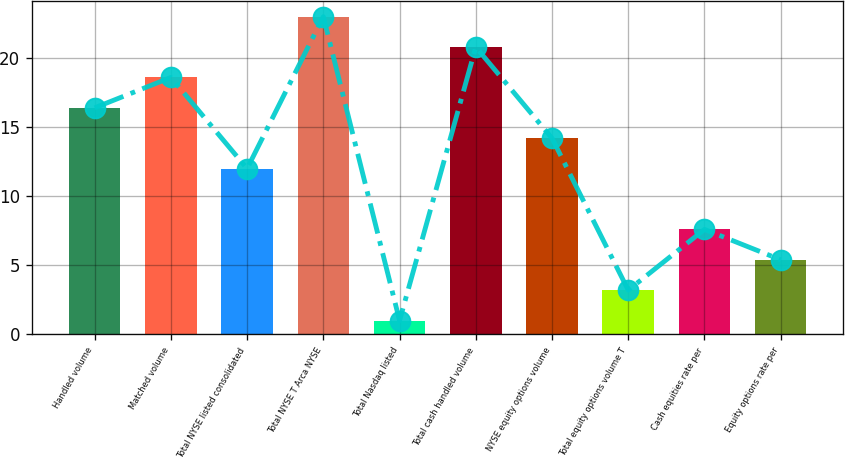Convert chart. <chart><loc_0><loc_0><loc_500><loc_500><bar_chart><fcel>Handled volume<fcel>Matched volume<fcel>Total NYSE listed consolidated<fcel>Total NYSE T Arca NYSE<fcel>Total Nasdaq listed<fcel>Total cash handled volume<fcel>NYSE equity options volume<fcel>Total equity options volume T<fcel>Cash equities rate per<fcel>Equity options rate per<nl><fcel>16.4<fcel>18.6<fcel>12<fcel>23<fcel>1<fcel>20.8<fcel>14.2<fcel>3.2<fcel>7.6<fcel>5.4<nl></chart> 